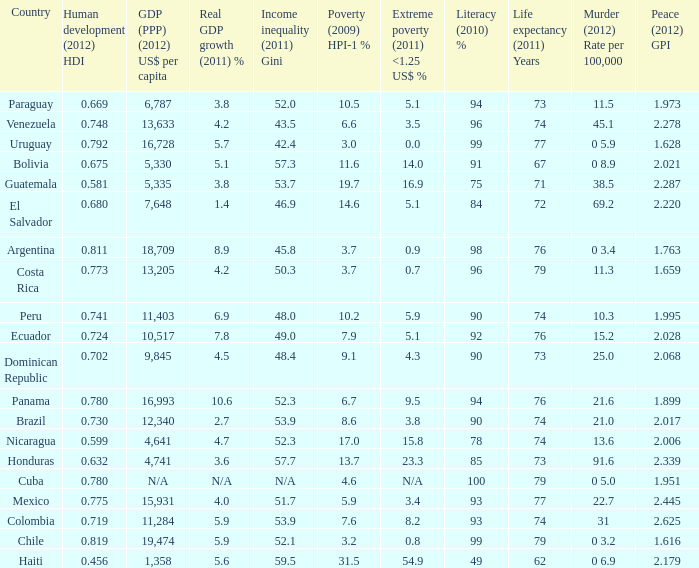What is the total poverty (2009) HPI-1 % when the extreme poverty (2011) <1.25 US$ % of 16.9, and the human development (2012) HDI is less than 0.581? None. 